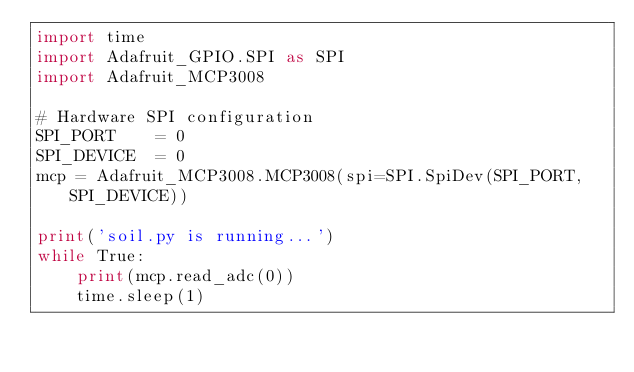<code> <loc_0><loc_0><loc_500><loc_500><_Python_>import time
import Adafruit_GPIO.SPI as SPI
import Adafruit_MCP3008

# Hardware SPI configuration
SPI_PORT    = 0
SPI_DEVICE  = 0
mcp = Adafruit_MCP3008.MCP3008(spi=SPI.SpiDev(SPI_PORT, SPI_DEVICE))

print('soil.py is running...')
while True:
    print(mcp.read_adc(0))
    time.sleep(1)</code> 